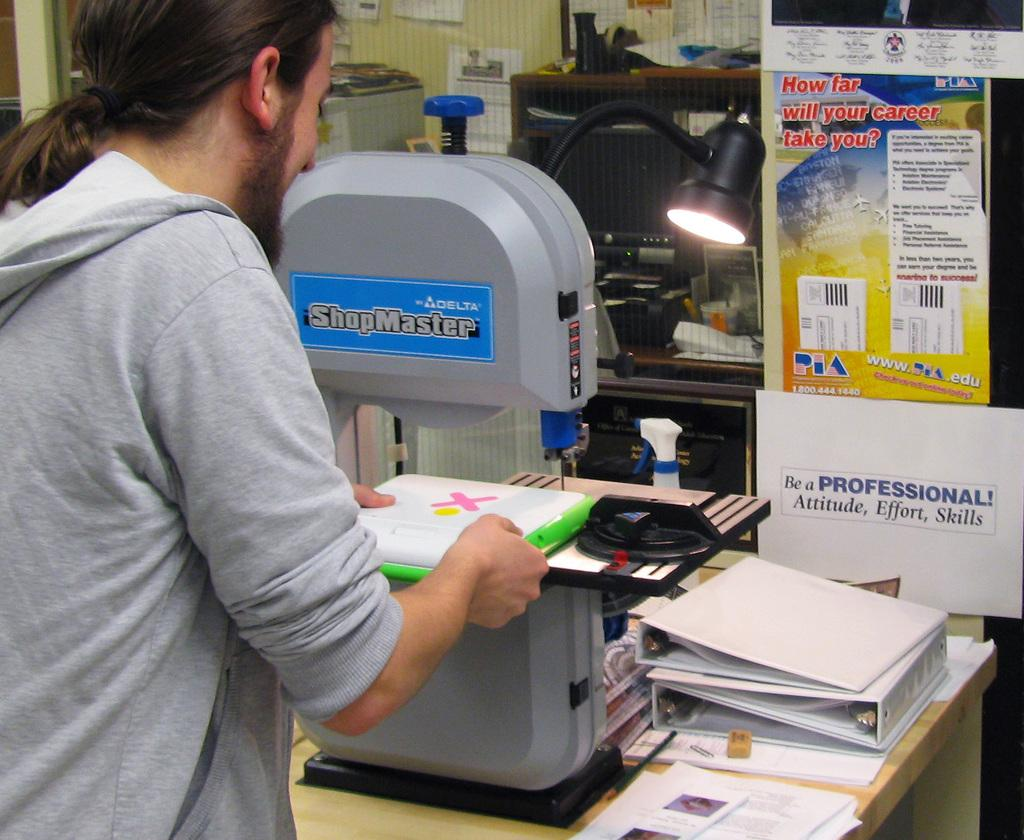<image>
Create a compact narrative representing the image presented. Delta shopmaster banner on a machine and a how far will your career take you poster. 